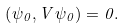Convert formula to latex. <formula><loc_0><loc_0><loc_500><loc_500>\left ( \psi _ { 0 } , V \psi _ { 0 } \right ) = 0 .</formula> 